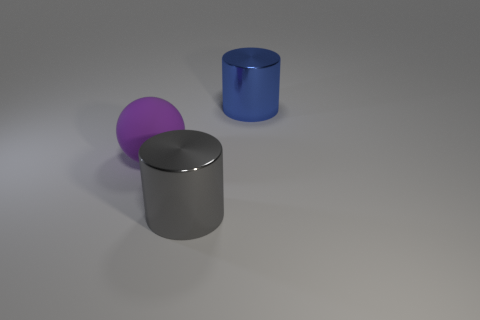Subtract all blue cylinders. How many cylinders are left? 1 Subtract 1 cylinders. How many cylinders are left? 1 Subtract all balls. How many objects are left? 2 Add 3 small purple metallic cylinders. How many objects exist? 6 Subtract 0 yellow balls. How many objects are left? 3 Subtract all gray cylinders. Subtract all green spheres. How many cylinders are left? 1 Subtract all cyan cylinders. How many red spheres are left? 0 Subtract all big red things. Subtract all big blue cylinders. How many objects are left? 2 Add 3 rubber balls. How many rubber balls are left? 4 Add 1 tiny purple metal objects. How many tiny purple metal objects exist? 1 